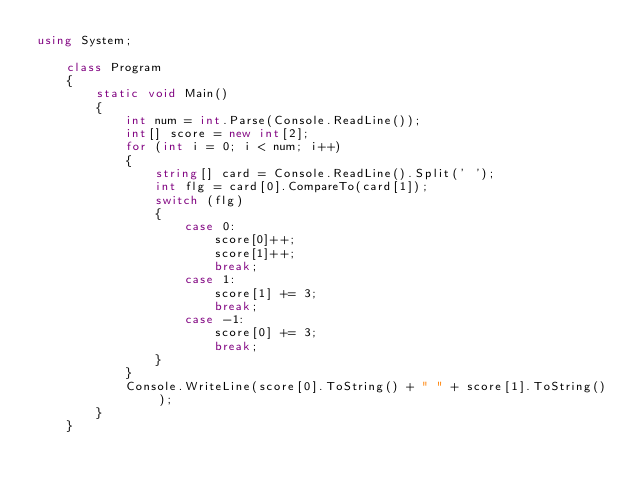<code> <loc_0><loc_0><loc_500><loc_500><_C#_>using System;

    class Program
    {
        static void Main()
        {
            int num = int.Parse(Console.ReadLine());
            int[] score = new int[2];
            for (int i = 0; i < num; i++)
            {
                string[] card = Console.ReadLine().Split(' ');
                int flg = card[0].CompareTo(card[1]);
                switch (flg)
                {
                    case 0:
                        score[0]++;
                        score[1]++;
                        break;
                    case 1:
                        score[1] += 3;
                        break;
                    case -1:
                        score[0] += 3;
                        break;
                }
            }
            Console.WriteLine(score[0].ToString() + " " + score[1].ToString());
        }
    }</code> 